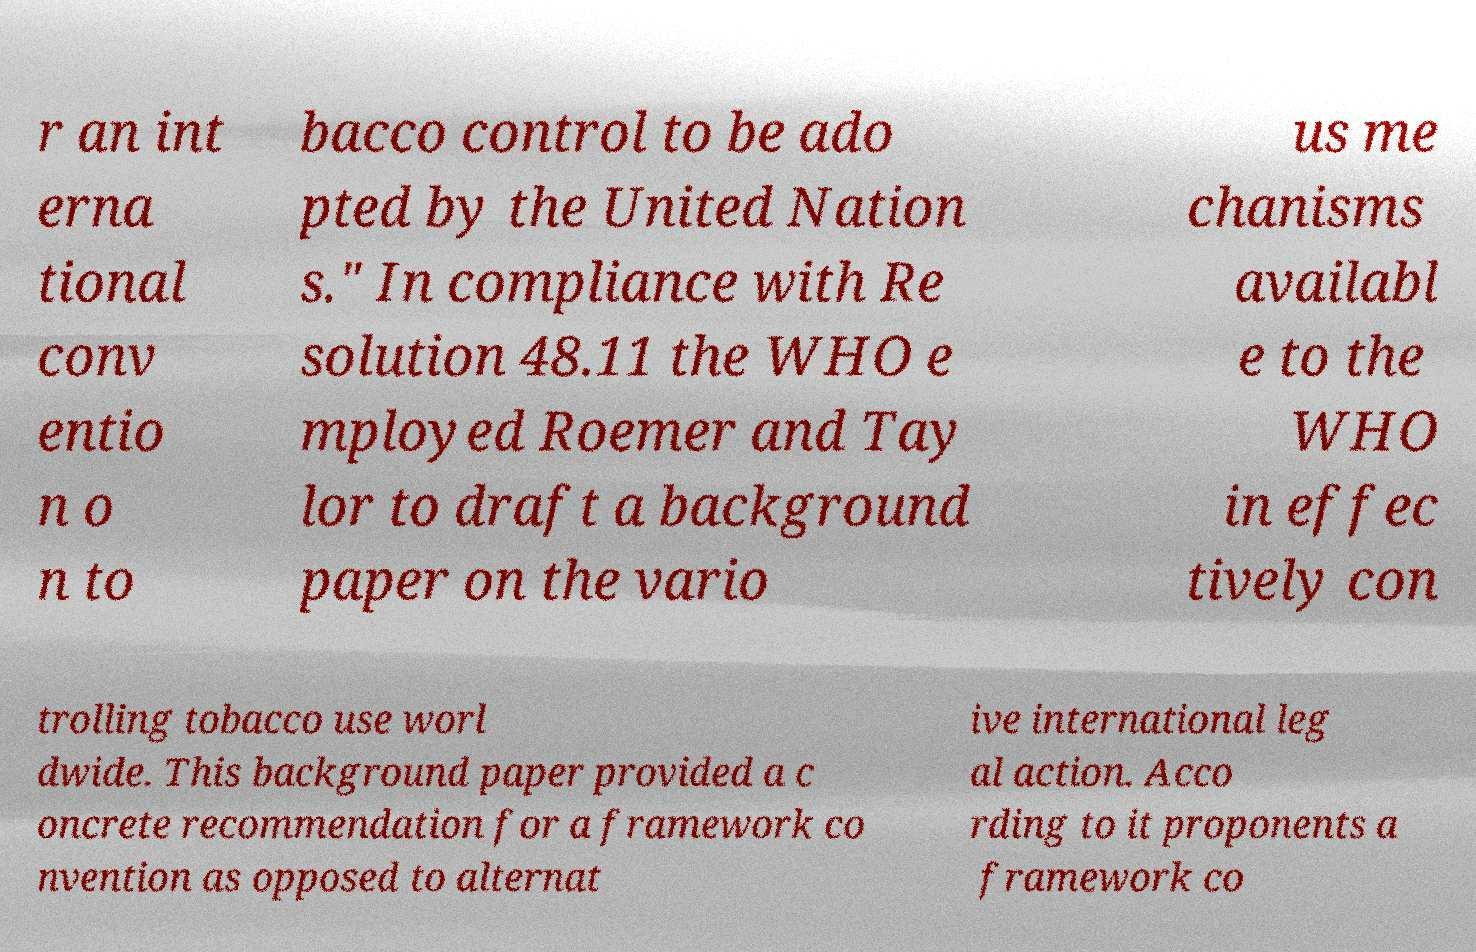Please read and relay the text visible in this image. What does it say? r an int erna tional conv entio n o n to bacco control to be ado pted by the United Nation s." In compliance with Re solution 48.11 the WHO e mployed Roemer and Tay lor to draft a background paper on the vario us me chanisms availabl e to the WHO in effec tively con trolling tobacco use worl dwide. This background paper provided a c oncrete recommendation for a framework co nvention as opposed to alternat ive international leg al action. Acco rding to it proponents a framework co 